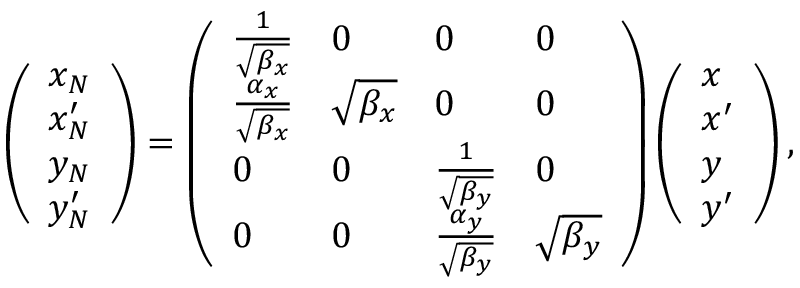Convert formula to latex. <formula><loc_0><loc_0><loc_500><loc_500>\left ( \begin{array} { l } { x _ { N } } \\ { x _ { N } ^ { \prime } } \\ { y _ { N } } \\ { y _ { N } ^ { \prime } } \end{array} \right ) = \left ( \begin{array} { l l l l } { \frac { 1 } { \sqrt { \beta _ { x } } } } & { 0 } & { 0 } & { 0 } \\ { \frac { \alpha _ { x } } { \sqrt { \beta _ { x } } } } & { \sqrt { \beta _ { x } } } & { 0 } & { 0 } \\ { 0 } & { 0 } & { \frac { 1 } { \sqrt { \beta _ { y } } } } & { 0 } \\ { 0 } & { 0 } & { \frac { \alpha _ { y } } { \sqrt { \beta _ { y } } } } & { \sqrt { \beta _ { y } } } \end{array} \right ) \left ( \begin{array} { l } { x } \\ { x ^ { \prime } } \\ { y } \\ { y ^ { \prime } } \end{array} \right ) ,</formula> 